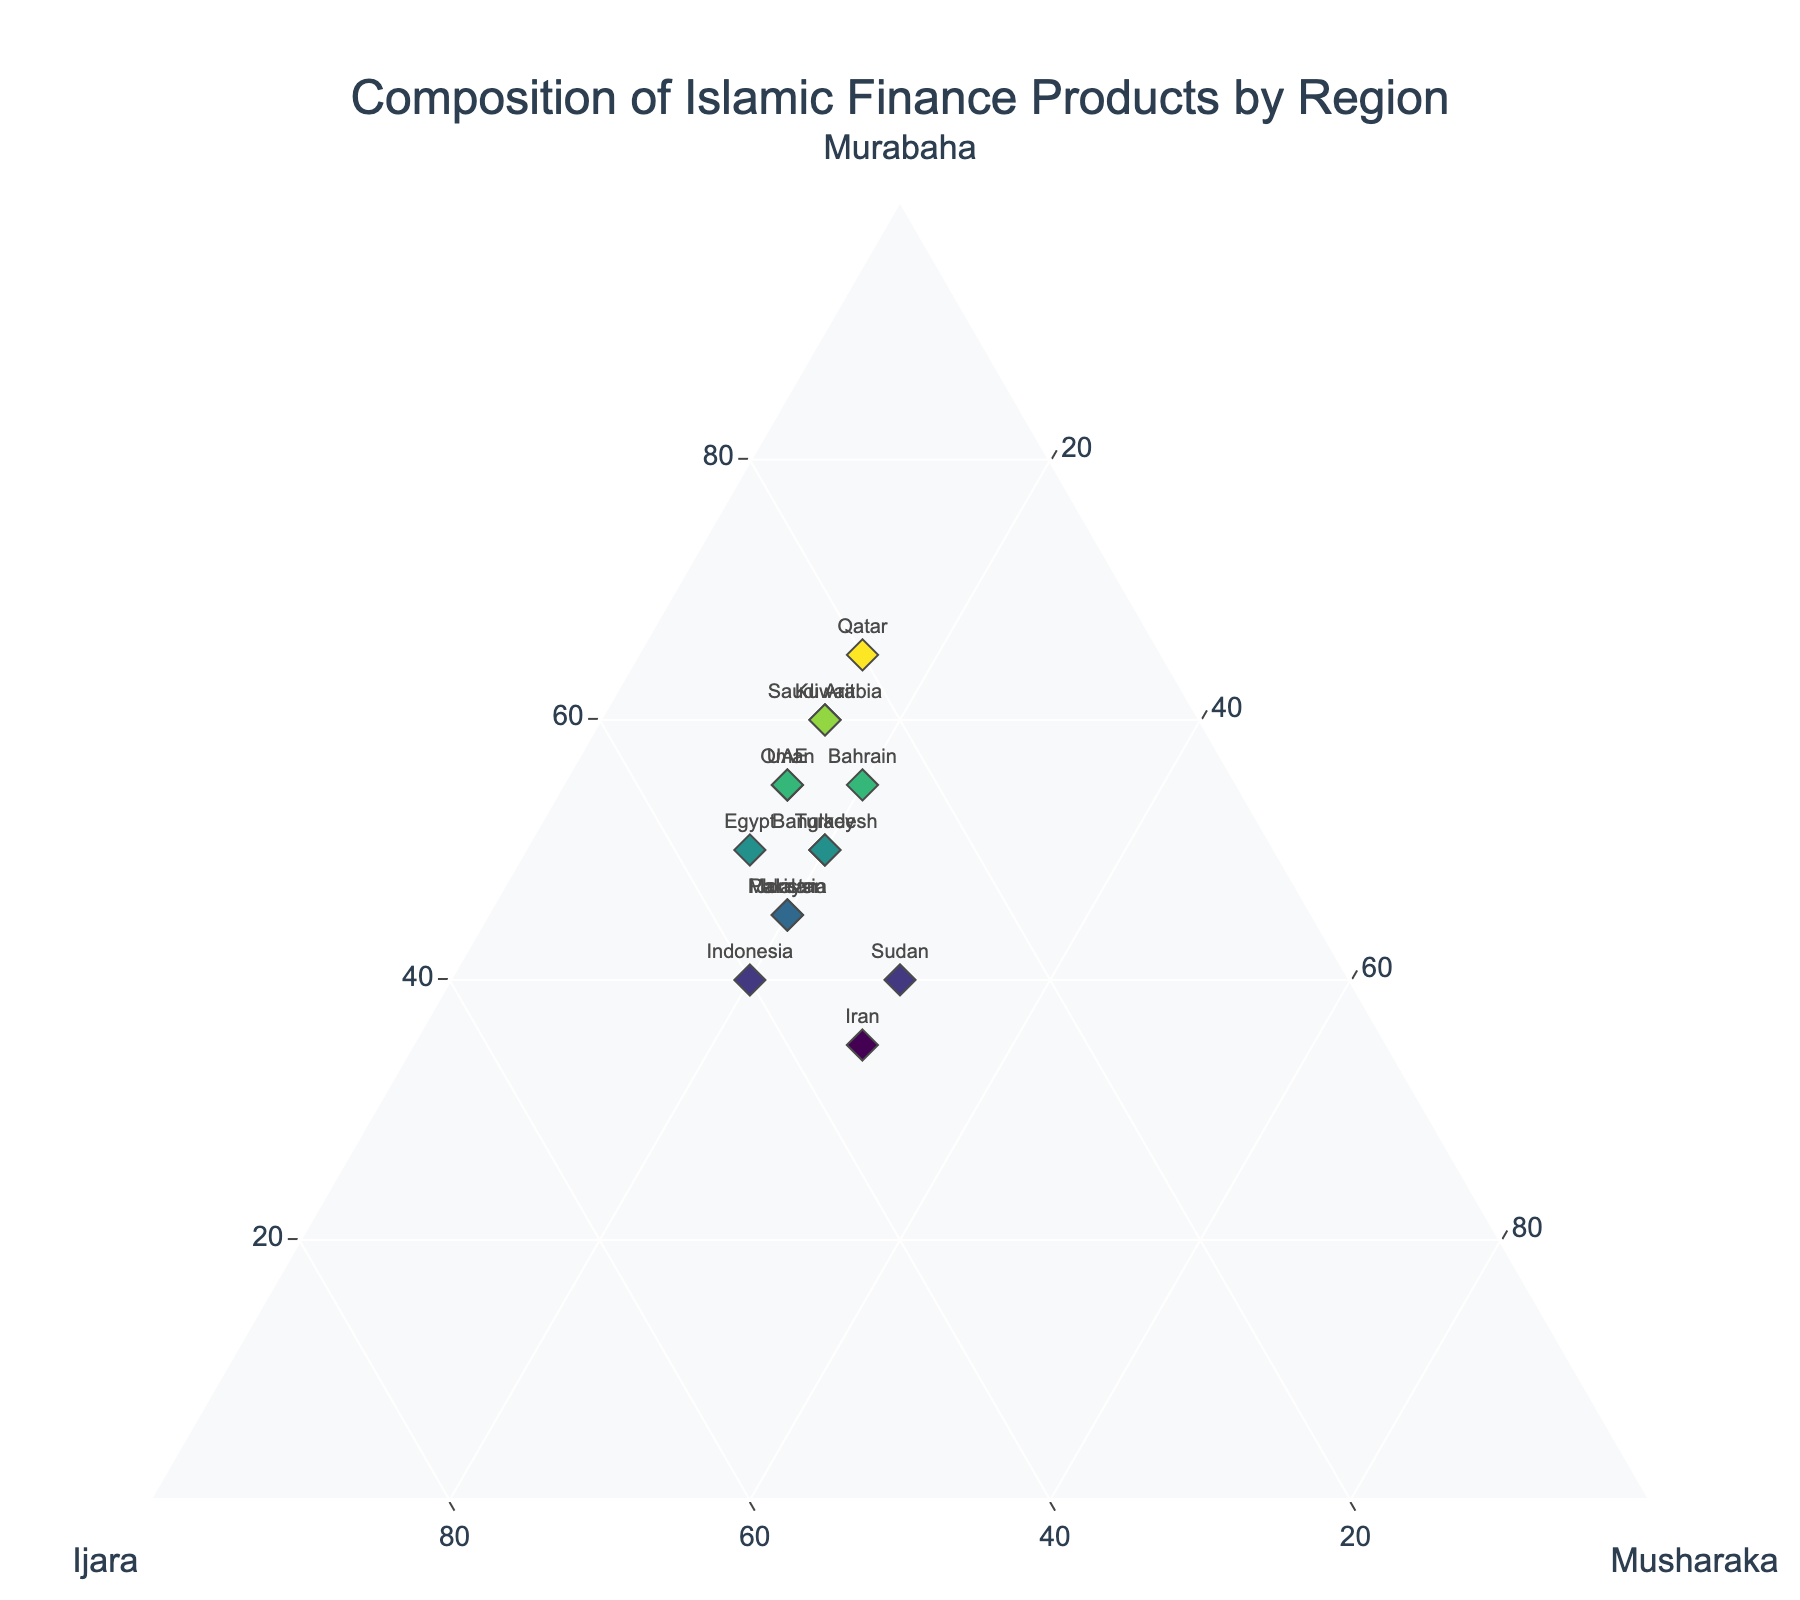What's the title of the figure? The title is usually displayed prominently at the top of the figure. In this case, it says "Composition of Islamic Finance Products by Region".
Answer: Composition of Islamic Finance Products by Region Which region has the highest Murabaha composition? To find this, we look at the apex closest to Murabaha. The region with the highest value in the Murabaha axis is Qatar with 65%.
Answer: Qatar What is the difference in Ijara composition between Malaysia and UAE? Malaysia has 35% Ijara, and UAE has 30%. The difference is calculated by subtracting the smaller value from the larger one, i.e., 35 - 30.
Answer: 5% Which regions have an equal composition of Musharaka? To answer this, we compare the Musharaka values. Sudan, Iran, and Bahrain all have 30% Musharaka.
Answer: Sudan, Iran, Bahrain What is the total percentage composition of Murabaha and Ijara for Indonesia? For Indonesia, Murabaha is 40% and Ijara is 40%. Adding these two values gives us 40 + 40.
Answer: 80% Which region has the most balanced composition among Murabaha, Ijara, and Musharaka? The most balanced composition would be the region whose values are closest to one another. Iran has Murabaha: 35%, Ijara: 35%, Musharaka: 30%, which seems the most balanced.
Answer: Iran How many regions have Murabaha compositions greater than 50%? Checking each region's Murabaha composition for values above 50%, we find: Saudi Arabia (60%), UAE (55%), Qatar (65%), Bahrain (55%), Kuwait (60%), and Oman (55%). This gives us a total of 6 regions.
Answer: 6 Which region has the highest combined composition of Murabaha and Musharaka? First, we sum Murabaha and Musharaka for each region. For Qatar, it's 65 + 15 = 80%. When compared with other regions, Qatar's combined score is the highest.
Answer: Qatar What is the average composition of Musharaka across all regions? The Musharaka values across all regions are: 15, 20, 15, 20, 20, 15, 20, 15, 20, 15, 15, 20, 30, 30, 20. Summing these gives 290, and there are 15 regions, so the average is 290/15.
Answer: 19.33% Which regions have a Murabaha composition that is less than Ijara? Comparing Murabaha and Ijara for each region, Indonesia (40% Murabaha, 40% Ijara), Iran (35% each), and Sudan (40% Murabaha, 30% Ijara) fit the criteria. However, only Sudan strictly has a lower Murabaha than Ijara.
Answer: Sudan 